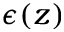<formula> <loc_0><loc_0><loc_500><loc_500>\epsilon ( z )</formula> 